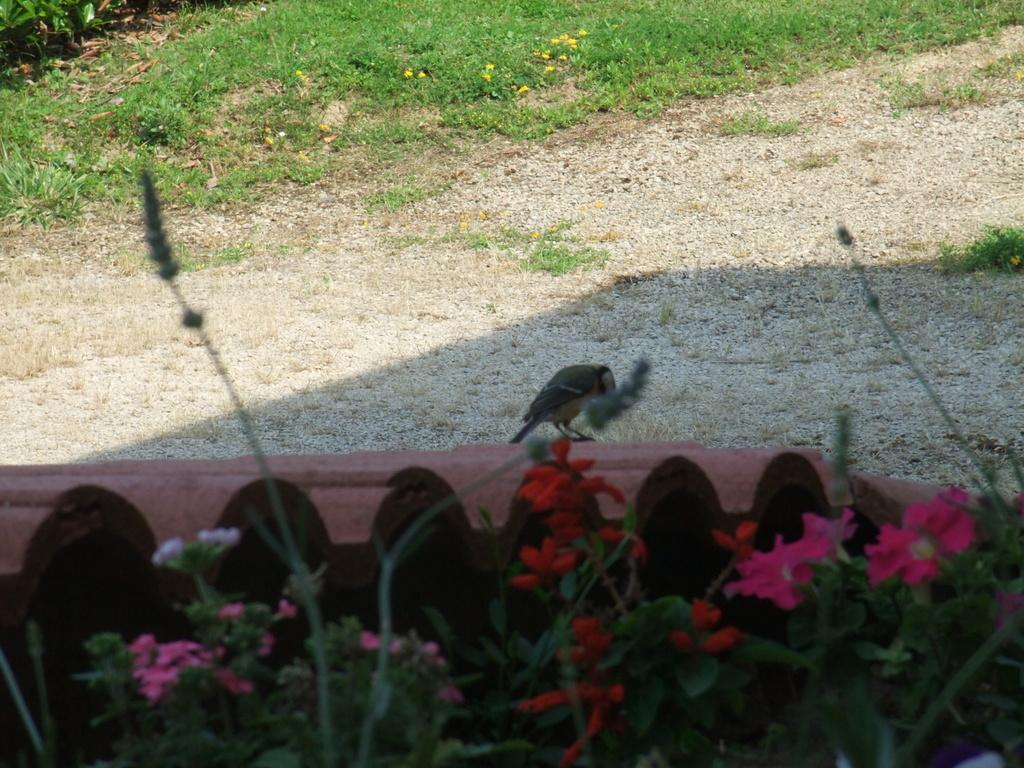What type of plants can be seen in the foreground of the image? There are flowering plants in the foreground of the image. What animal is sitting in the foreground of the image? A bird is sitting on a fence in the foreground of the image. What type of vegetation is visible in the background of the image? There is grass visible in the background of the image. What is the weather like in the image? The image appears to have been taken on a sunny day. What type of holiday is being celebrated in the image? There is no indication of a holiday being celebrated in the image. What type of patch can be seen on the bird's wing in the image? There is no bird with a patch visible in the image. 